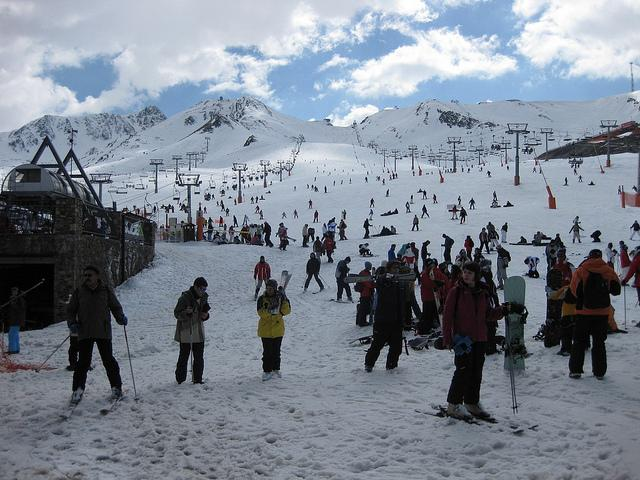How could someone near here gain elevation without expending a lot of energy? Please explain your reasoning. ski lift. The ski lift will bring you up while you are sitting down. 